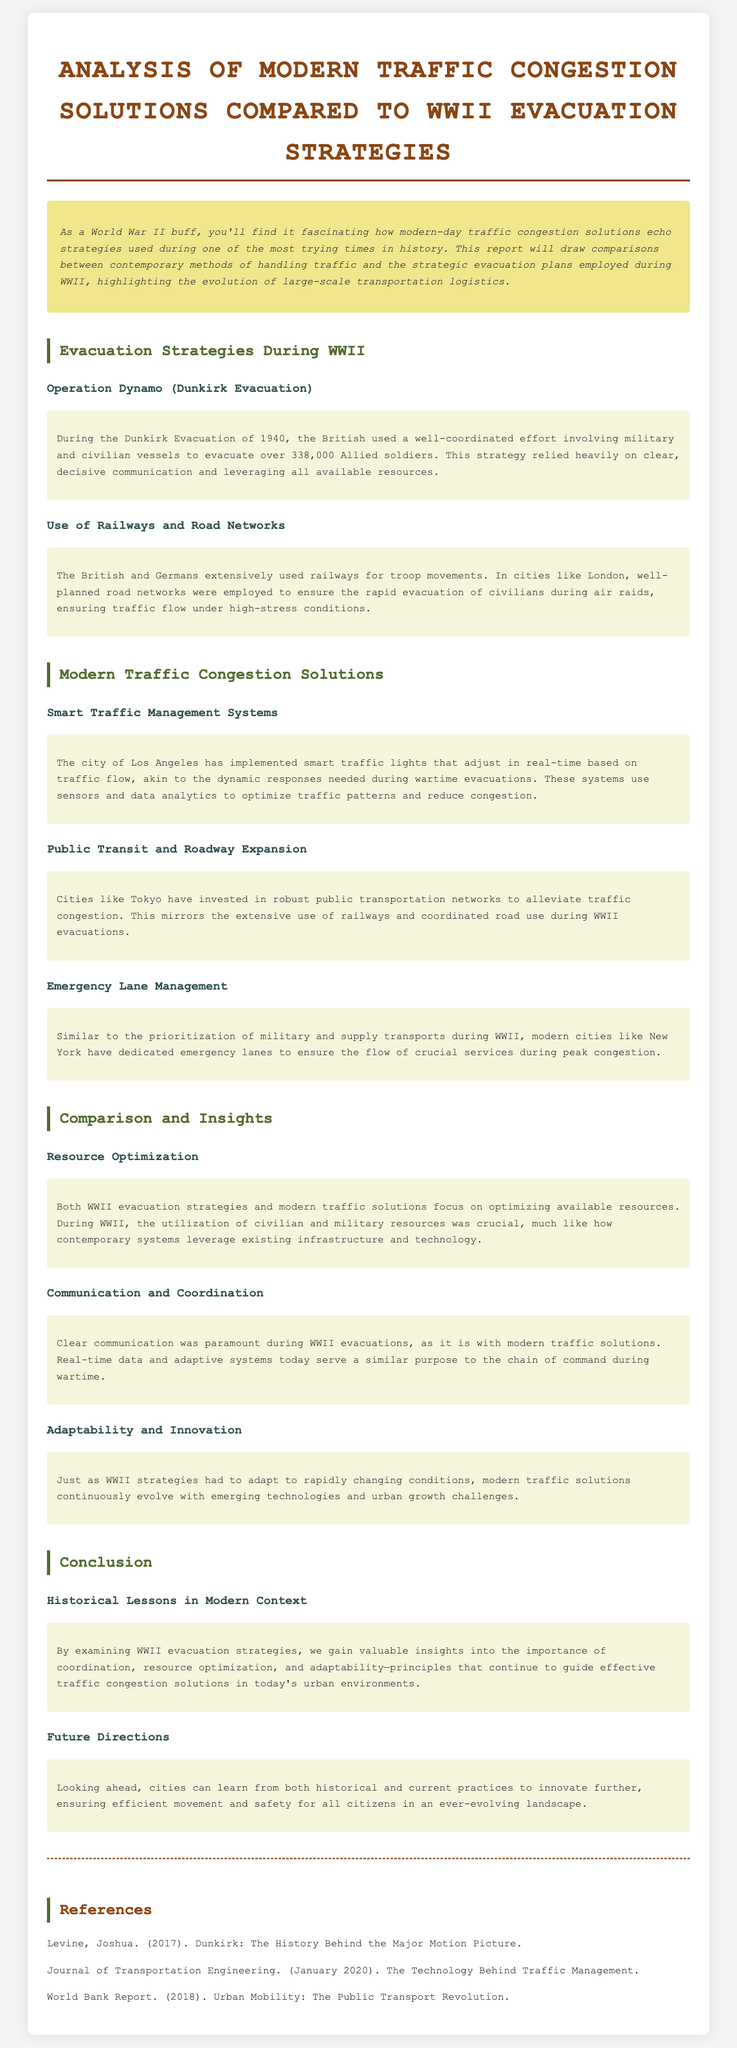what was the Dunkirk Evacuation year? The Dunkirk Evacuation occurred in 1940.
Answer: 1940 how many Allied soldiers were evacuated during Operation Dynamo? Operation Dynamo successfully evacuated over 338,000 Allied soldiers.
Answer: over 338,000 which city implemented smart traffic lights? The city of Los Angeles implemented smart traffic lights that adjust in real-time.
Answer: Los Angeles what is a modern solution akin to wartime resource optimization? Modern traffic solutions focus on optimizing available resources.
Answer: optimizing available resources what principle is emphasized for both WWII evacuations and modern traffic solutions? Clear communication is paramount during both WWII evacuations and modern traffic solutions.
Answer: Clear communication 